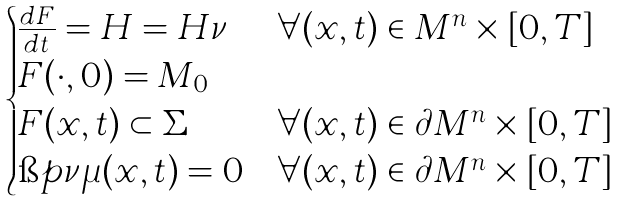Convert formula to latex. <formula><loc_0><loc_0><loc_500><loc_500>\begin{cases} \frac { d F } { d t } = H = H \nu & \forall ( x , t ) \in M ^ { n } \times [ 0 , T ] \\ F ( \cdot , 0 ) = M _ { 0 } & \\ F ( x , t ) \subset \Sigma & \forall ( x , t ) \in \partial M ^ { n } \times [ 0 , T ] \\ \i p { \nu } { \mu } ( x , t ) = 0 & \forall ( x , t ) \in \partial M ^ { n } \times [ 0 , T ] \\ \end{cases}</formula> 